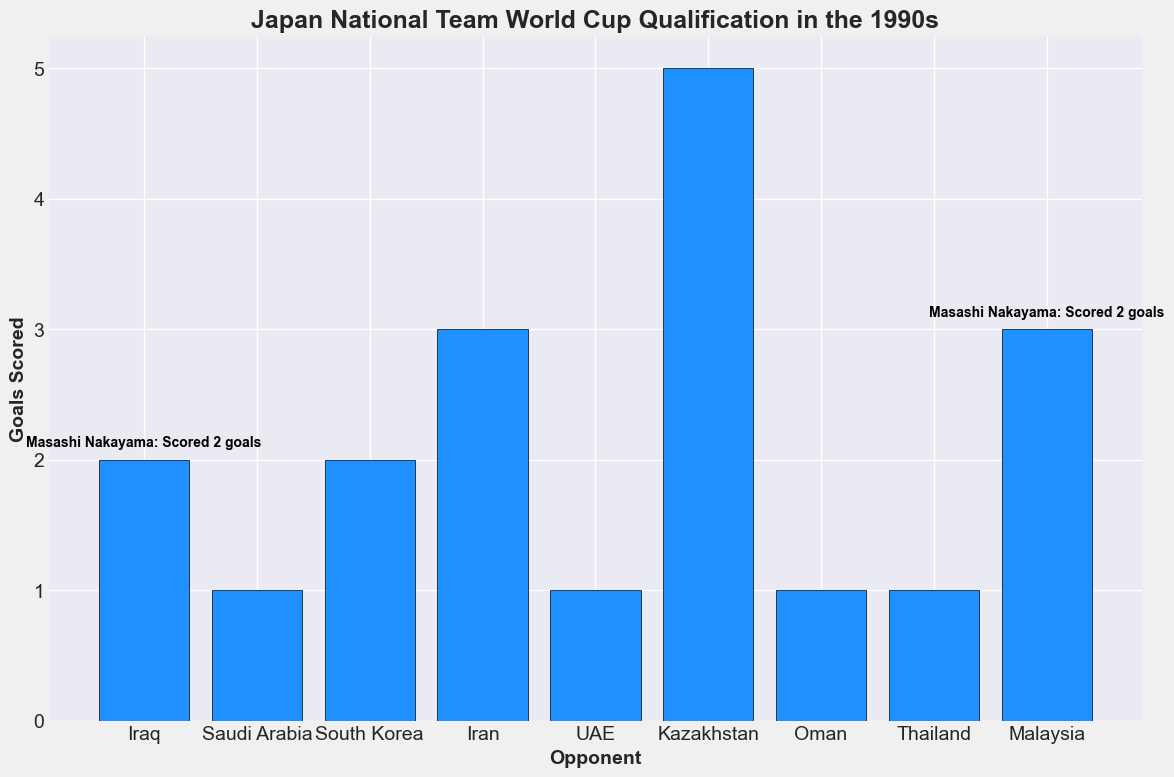Which opponent did Japan score the most goals against? The tallest bar in the chart represents the number of goals scored by Japan. By visually comparing the heights of the bars, the highest one corresponds to the match against Kazakhstan, where Japan scored 5 goals.
Answer: Kazakhstan Which two matches are annotated with text about key player performances, and what were the players' contributions? The figure includes text annotations on two specific bars. The first one (against Iraq) mentions Masashi Nakayama scoring 2 goals, and the last one (against Oman) mentions Shinji Ono scoring 1 goal.
Answer: Iraq and Oman; Masashi Nakayama scored 2 goals, Shinji Ono scored 1 goal Which match had the same number of goals scored by Japan as the match against Oman? Comparing the height of the bars, both the matches against Saudi Arabia and UAE show a similar bar height to that of Oman, indicating 1 goal scored.
Answer: Saudi Arabia and UAE How many total goals did Japan score in 1993 during the World Cup qualification journey? Add the goals from 1993: 2 (Iraq) + 1 (Saudi Arabia) + 1 (Thailand) + 3 (Malaysia) = 7 goals.
Answer: 7 In which match did Masashi Nakayama score 2 goals and still result in a draw? By locating the bar with an annotation specifying 2 goals by Masashi Nakayama and where the result was a draw, we identify the match against Iraq.
Answer: Iraq How did Masashi Nakayama's performances change from the matches in 1993 to 1997 based on the annotated data? In 1993, Nakayama scored 1 or 2 goals in the annotated match against Iraq. In 1997, he scored 1 goal against South Korea and 2 goals against Kazakhstan, indicating consistent high performance.
Answer: Consistent high performance, scoring 1 or 2 goals Which match had the highest number of goals scored by Japan in the Final Round of 1997, and who was the key player? Looking at the bars corresponding to the Final Round of 1997, the highest bar is against Kazakhstan, where Masashi Nakayama was the key player scoring 2 goals.
Answer: Kazakhstan; Masashi Nakayama How many total goals were assisted by Hidetoshi Nakata in the 1997 Final Round? Nakata's performance stats include 2 assists in the match against Iran in 1997. Summing up all his assists from this round: 2.
Answer: 2 Which matches resulted in a draw where Japan scored at least one goal? By identifying the bars for matches with "Result" values indicating a draw (x-x), and checking if Japan scored at least once: Iraq (2-2), Saudi Arabia (1-1), UAE (1-1), and Oman (1-1).
Answer: Iraq, Saudi Arabia, UAE, Oman 